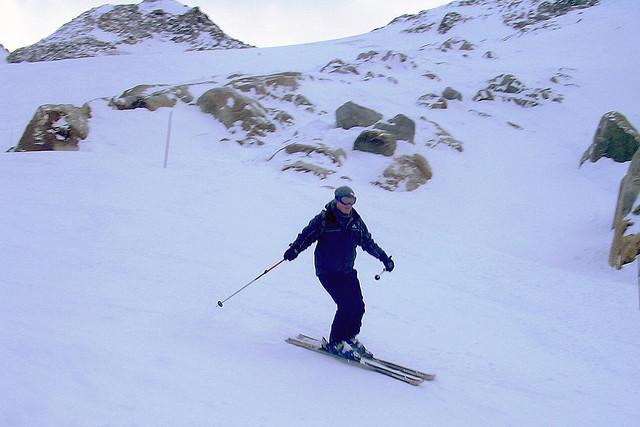What is the person doing?
Answer briefly. Skiing. Are the poles touching the snow?
Answer briefly. No. Is the person skiing downhill?
Write a very short answer. Yes. 